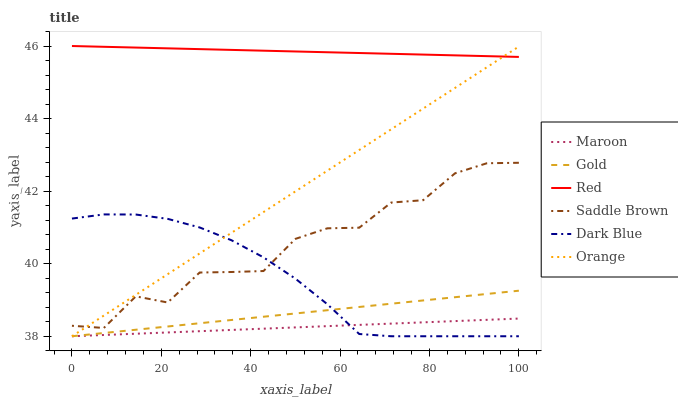Does Maroon have the minimum area under the curve?
Answer yes or no. Yes. Does Red have the maximum area under the curve?
Answer yes or no. Yes. Does Dark Blue have the minimum area under the curve?
Answer yes or no. No. Does Dark Blue have the maximum area under the curve?
Answer yes or no. No. Is Red the smoothest?
Answer yes or no. Yes. Is Saddle Brown the roughest?
Answer yes or no. Yes. Is Maroon the smoothest?
Answer yes or no. No. Is Maroon the roughest?
Answer yes or no. No. Does Saddle Brown have the lowest value?
Answer yes or no. No. Does Dark Blue have the highest value?
Answer yes or no. No. Is Gold less than Saddle Brown?
Answer yes or no. Yes. Is Red greater than Maroon?
Answer yes or no. Yes. Does Gold intersect Saddle Brown?
Answer yes or no. No. 